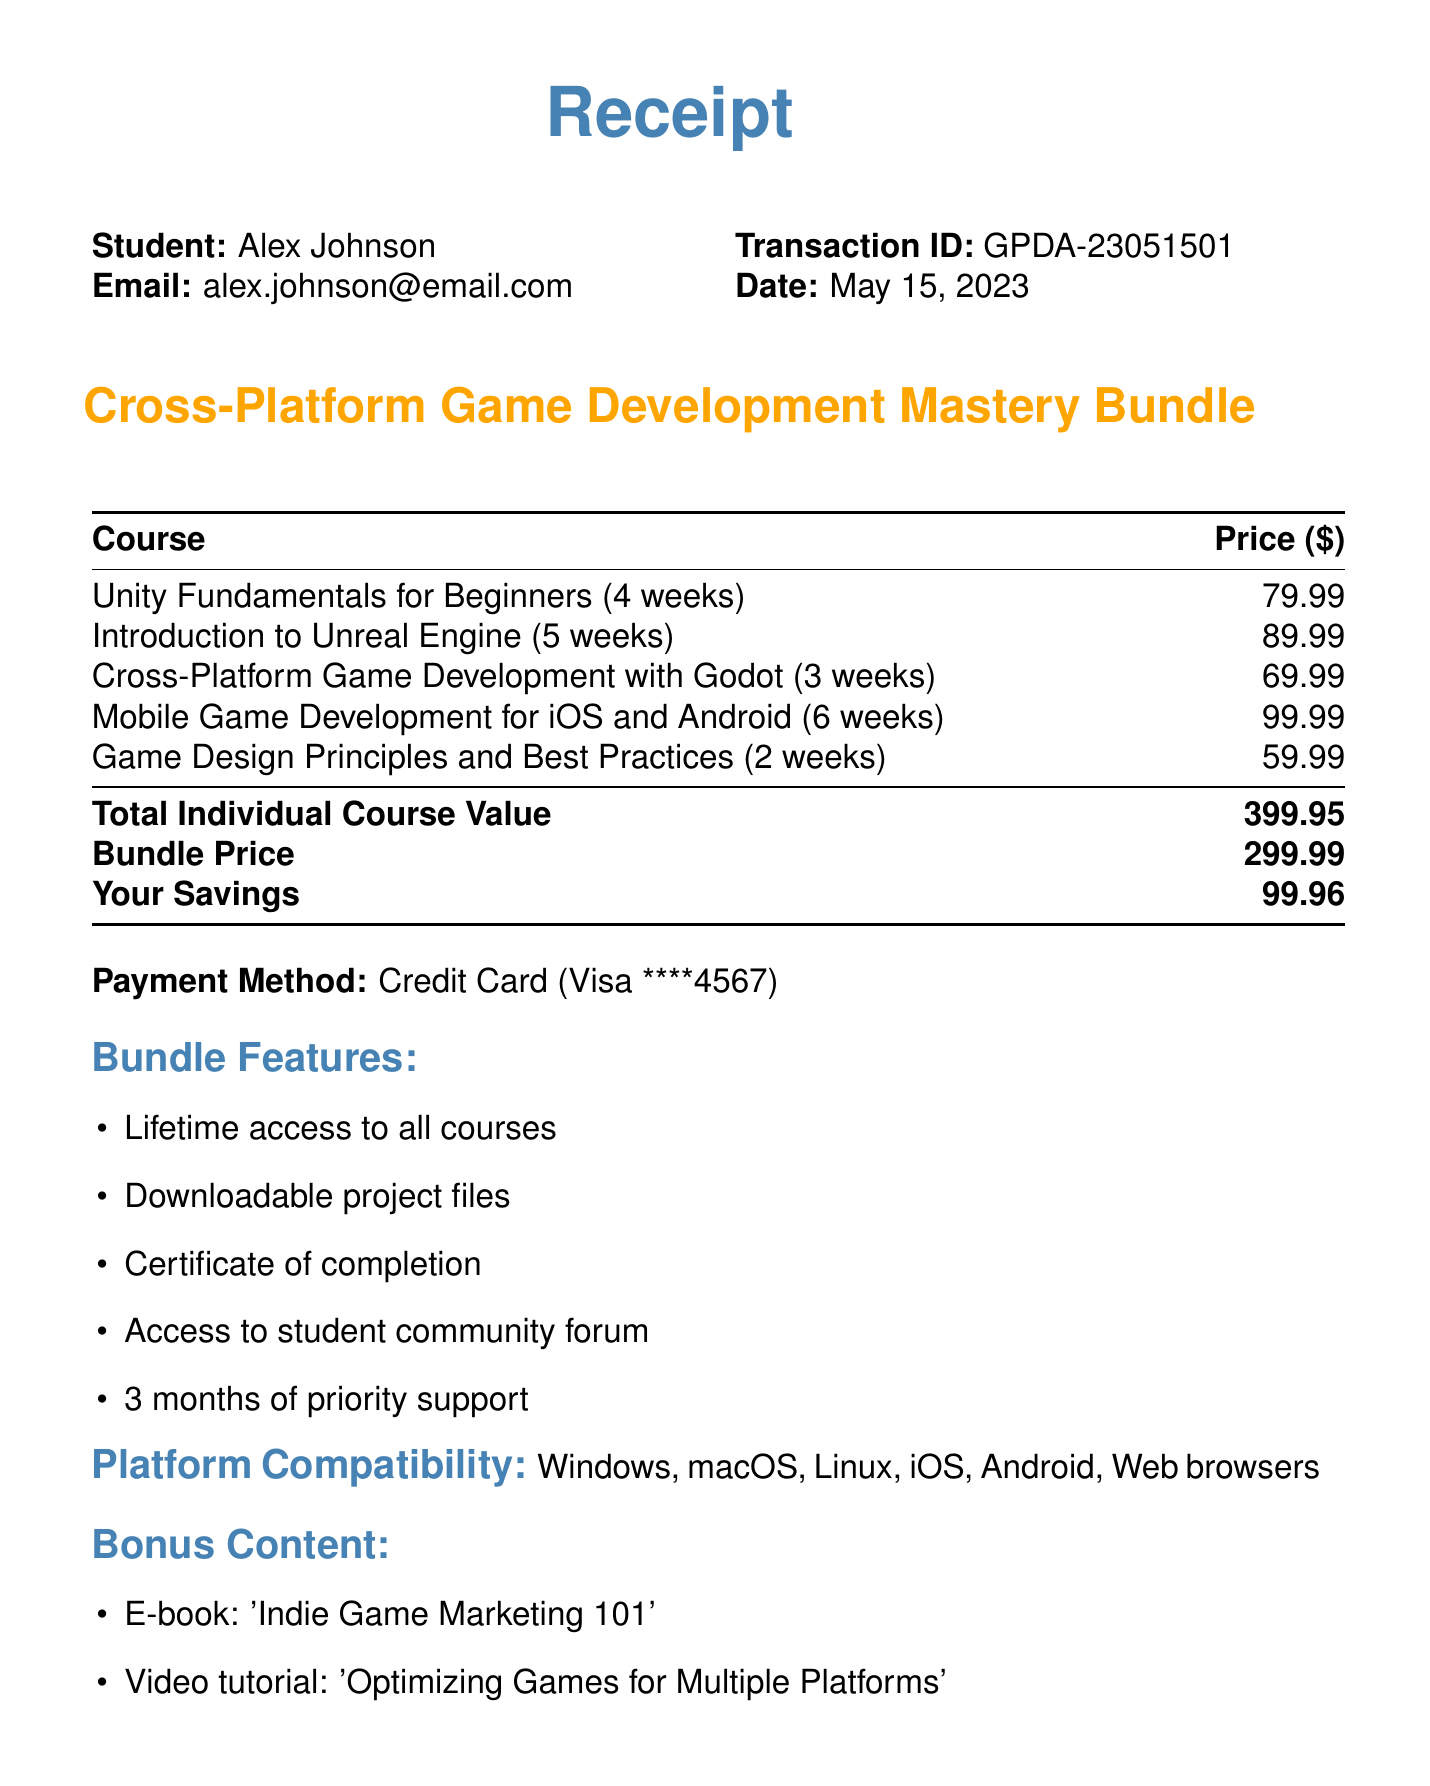What is the name of the bundle? The name of the bundle is stated clearly in the document as "Cross-Platform Game Development Mastery Bundle."
Answer: Cross-Platform Game Development Mastery Bundle Who is the student? The document specifies the name of the student as listed near the top of the receipt.
Answer: Alex Johnson What is the total savings from the bundle? The total savings is indicated in the pricing section of the document.
Answer: 99.96 What is the duration of the course “Introduction to Unreal Engine”? The document includes the duration for each course listed.
Answer: 5 weeks What payment method was used? The document states the payment method clearly, which is mentioned in the payment section.
Answer: Credit Card How many bonus content items are included in the bundle? The document lists the bonus content items, allowing us to count them.
Answer: 3 What is the price of Aseprite? The price of recommended tools is provided in the document, including Aseprite.
Answer: 19.99 Which platforms are compatible with the courses? The document lists the platform compatibility in a specific section.
Answer: Windows, macOS, Linux, iOS, Android, Web browsers What is the transaction date? The transaction date is recorded in the transaction details of the document.
Answer: May 15, 2023 